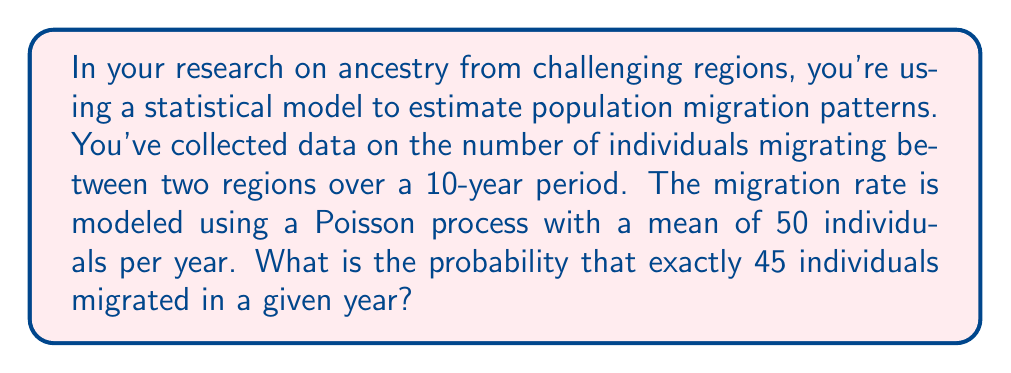What is the answer to this math problem? To solve this problem, we need to use the Poisson distribution, which is commonly used to model the number of events occurring in a fixed interval of time or space when these events happen with a known average rate.

The Poisson probability mass function is given by:

$$P(X = k) = \frac{e^{-\lambda} \lambda^k}{k!}$$

Where:
- $\lambda$ is the average rate of events per interval
- $k$ is the number of events we're interested in
- $e$ is Euler's number (approximately 2.71828)

In this case:
- $\lambda = 50$ (mean of 50 individuals per year)
- $k = 45$ (we're interested in exactly 45 individuals)

Let's substitute these values into the formula:

$$P(X = 45) = \frac{e^{-50} 50^{45}}{45!}$$

To calculate this:

1. Calculate $e^{-50}$:
   $e^{-50} \approx 1.9287 \times 10^{-22}$

2. Calculate $50^{45}$:
   $50^{45} \approx 1.1259 \times 10^{76}$

3. Calculate $45!$:
   $45! \approx 1.1962 \times 10^{56}$

4. Combine these values:
   $$\frac{(1.9287 \times 10^{-22}) \times (1.1259 \times 10^{76})}{1.1962 \times 10^{56}} \approx 0.0182$$

Therefore, the probability of exactly 45 individuals migrating in a given year is approximately 0.0182 or 1.82%.
Answer: $P(X = 45) \approx 0.0182$ or 1.82% 